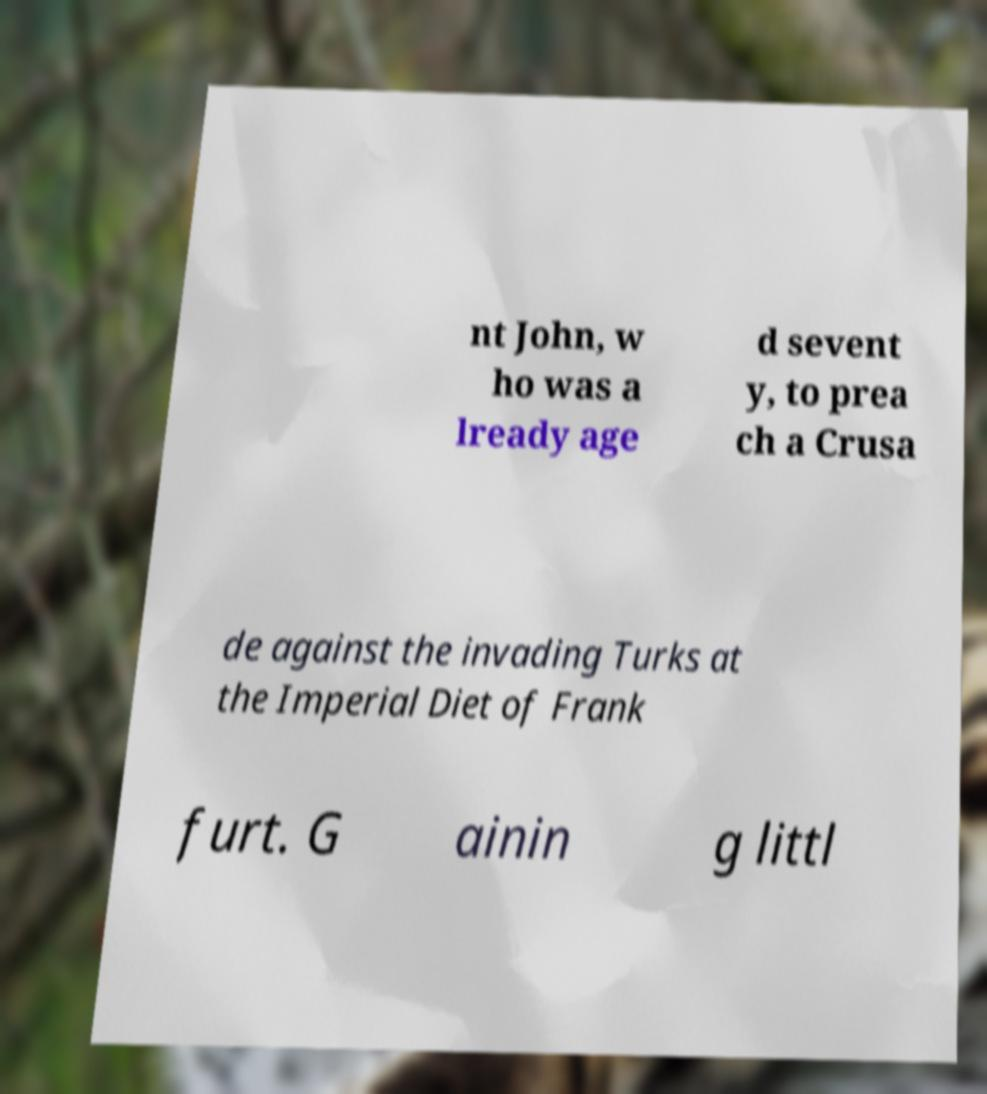For documentation purposes, I need the text within this image transcribed. Could you provide that? nt John, w ho was a lready age d sevent y, to prea ch a Crusa de against the invading Turks at the Imperial Diet of Frank furt. G ainin g littl 